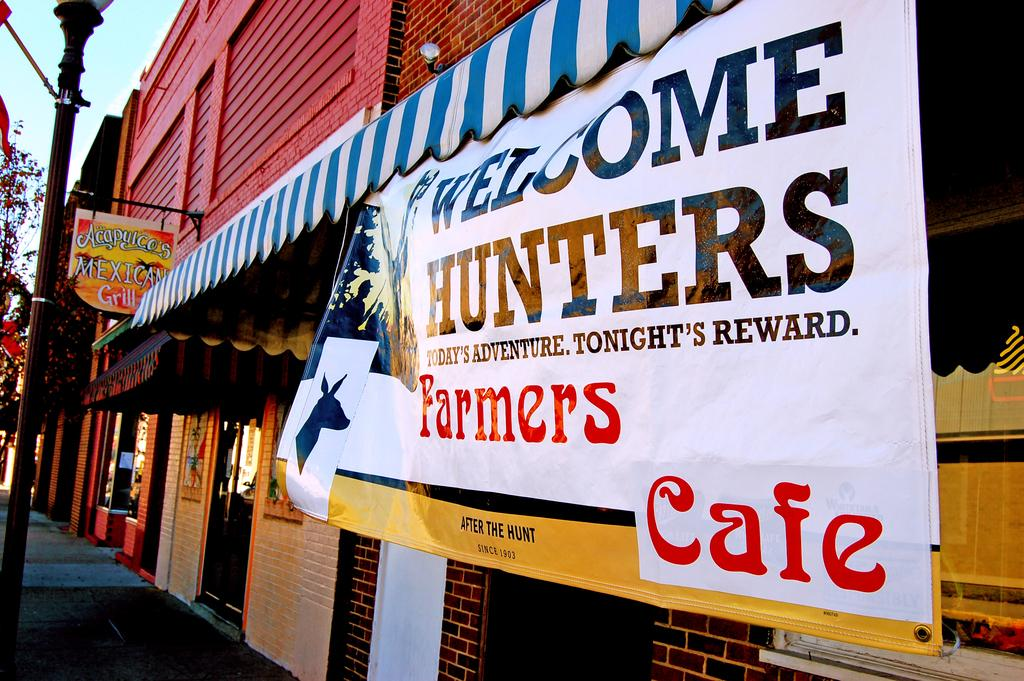What is the main structure in the center of the image? There is a building in the center of the image. What can be seen on the sides or surrounding the building? There is a wall, a banner, a sign board, a pole, a glass window, flags, trees, and other objects in the image. What is visible in the background of the image? The sky is visible in the background of the image, with clouds present. What type of mint is growing on the building in the image? There is no mint growing on the building in the image. Can you see the mom of the person who took the picture in the image? There is no person visible in the image, so it is impossible to determine if their mom is present. 